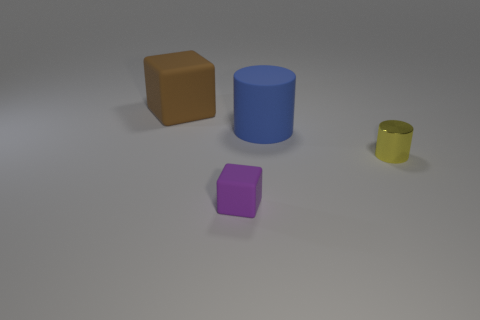Can you describe the colors of the objects in the image? Certainly, there are four objects with distinct colors. A brown cube, a blue cylinder, a smaller yellow cylinder, and a purple cube. 